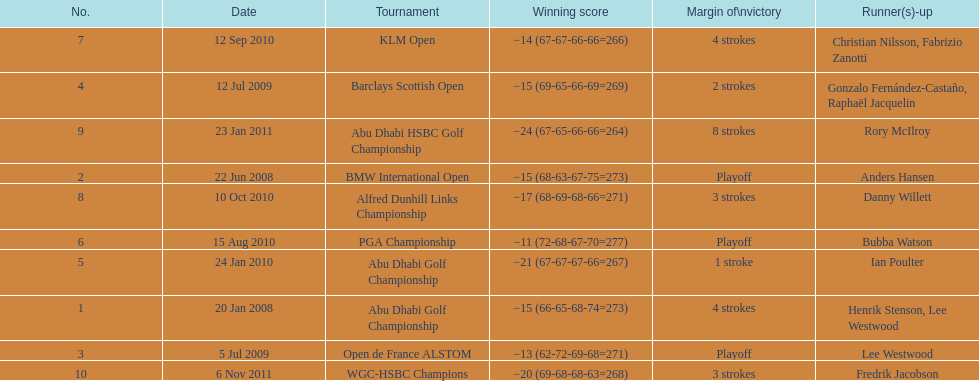How many total tournaments has he won? 10. 